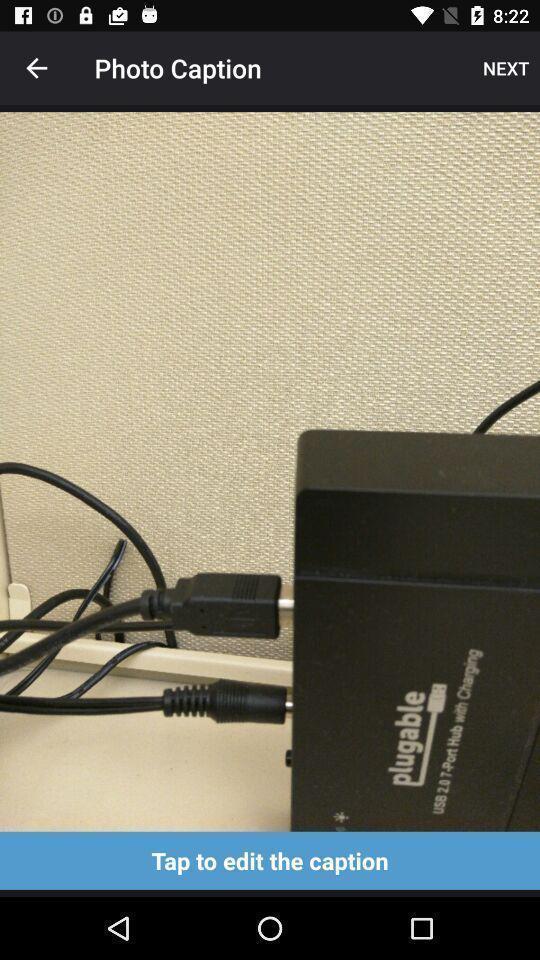Describe this image in words. Screen displaying an image with a edit caption option. 